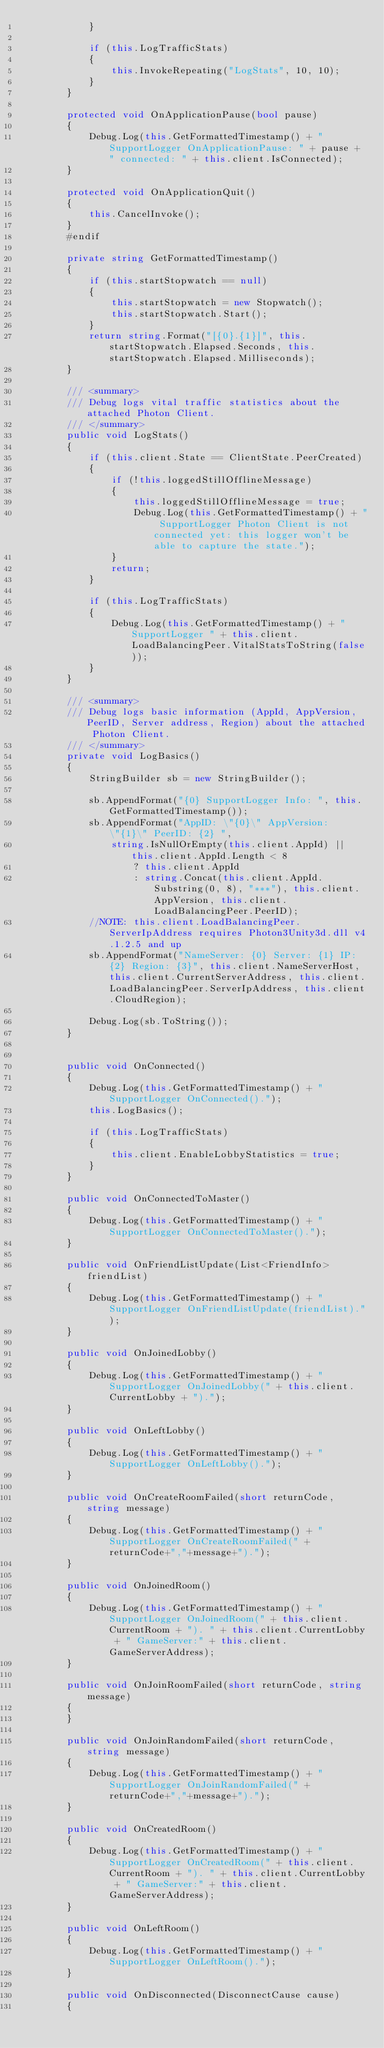<code> <loc_0><loc_0><loc_500><loc_500><_C#_>            }

            if (this.LogTrafficStats)
            {
                this.InvokeRepeating("LogStats", 10, 10);
            }
        }

        protected void OnApplicationPause(bool pause)
        {
            Debug.Log(this.GetFormattedTimestamp() + " SupportLogger OnApplicationPause: " + pause + " connected: " + this.client.IsConnected);
        }

        protected void OnApplicationQuit()
        {
            this.CancelInvoke();
        }
        #endif

        private string GetFormattedTimestamp()
        {
            if (this.startStopwatch == null)
            {
                this.startStopwatch = new Stopwatch();
                this.startStopwatch.Start();
            }
            return string.Format("[{0}.{1}]", this.startStopwatch.Elapsed.Seconds, this.startStopwatch.Elapsed.Milliseconds);
        }

        /// <summary>
        /// Debug logs vital traffic statistics about the attached Photon Client.
        /// </summary>
        public void LogStats()
        {
            if (this.client.State == ClientState.PeerCreated)
            {
                if (!this.loggedStillOfflineMessage)
                {
                    this.loggedStillOfflineMessage = true;
                    Debug.Log(this.GetFormattedTimestamp() + " SupportLogger Photon Client is not connected yet: this logger won't be able to capture the state.");
                }
                return;
            }

            if (this.LogTrafficStats)
            {
                Debug.Log(this.GetFormattedTimestamp() + " SupportLogger " + this.client.LoadBalancingPeer.VitalStatsToString(false));
            }
        }

        /// <summary>
        /// Debug logs basic information (AppId, AppVersion, PeerID, Server address, Region) about the attached Photon Client.
        /// </summary>
        private void LogBasics()
        {
            StringBuilder sb = new StringBuilder();

            sb.AppendFormat("{0} SupportLogger Info: ", this.GetFormattedTimestamp());
            sb.AppendFormat("AppID: \"{0}\" AppVersion: \"{1}\" PeerID: {2} ",
                string.IsNullOrEmpty(this.client.AppId) || this.client.AppId.Length < 8
                    ? this.client.AppId
                    : string.Concat(this.client.AppId.Substring(0, 8), "***"), this.client.AppVersion, this.client.LoadBalancingPeer.PeerID);
            //NOTE: this.client.LoadBalancingPeer.ServerIpAddress requires Photon3Unity3d.dll v4.1.2.5 and up
            sb.AppendFormat("NameServer: {0} Server: {1} IP: {2} Region: {3}", this.client.NameServerHost, this.client.CurrentServerAddress, this.client.LoadBalancingPeer.ServerIpAddress, this.client.CloudRegion);

            Debug.Log(sb.ToString());
        }


        public void OnConnected()
        {
            Debug.Log(this.GetFormattedTimestamp() + " SupportLogger OnConnected().");
            this.LogBasics();

            if (this.LogTrafficStats)
            {
                this.client.EnableLobbyStatistics = true;
            }
        }

        public void OnConnectedToMaster()
        {
			Debug.Log(this.GetFormattedTimestamp() + " SupportLogger OnConnectedToMaster().");
        }

        public void OnFriendListUpdate(List<FriendInfo> friendList)
        {
			Debug.Log(this.GetFormattedTimestamp() + " SupportLogger OnFriendListUpdate(friendList).");
        }

        public void OnJoinedLobby()
        {
            Debug.Log(this.GetFormattedTimestamp() + " SupportLogger OnJoinedLobby(" + this.client.CurrentLobby + ").");
        }

        public void OnLeftLobby()
        {
			Debug.Log(this.GetFormattedTimestamp() + " SupportLogger OnLeftLobby().");
        }

        public void OnCreateRoomFailed(short returnCode, string message)
        {
			Debug.Log(this.GetFormattedTimestamp() + " SupportLogger OnCreateRoomFailed(" + returnCode+","+message+").");
        }

        public void OnJoinedRoom()
        {
            Debug.Log(this.GetFormattedTimestamp() + " SupportLogger OnJoinedRoom(" + this.client.CurrentRoom + "). " + this.client.CurrentLobby + " GameServer:" + this.client.GameServerAddress);
        }

        public void OnJoinRoomFailed(short returnCode, string message)
        {
        }

        public void OnJoinRandomFailed(short returnCode, string message)
        {
			Debug.Log(this.GetFormattedTimestamp() + " SupportLogger OnJoinRandomFailed(" + returnCode+","+message+").");
        }

        public void OnCreatedRoom()
        {
            Debug.Log(this.GetFormattedTimestamp() + " SupportLogger OnCreatedRoom(" + this.client.CurrentRoom + "). " + this.client.CurrentLobby + " GameServer:" + this.client.GameServerAddress);
        }

        public void OnLeftRoom()
        {
            Debug.Log(this.GetFormattedTimestamp() + " SupportLogger OnLeftRoom().");
        }

		public void OnDisconnected(DisconnectCause cause)
        {</code> 